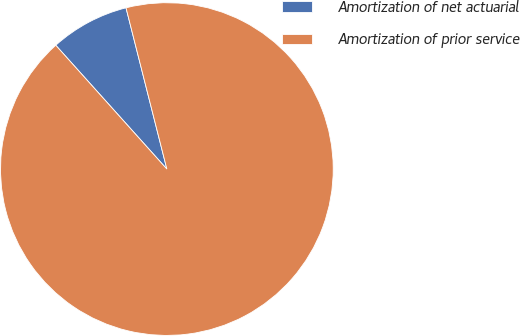<chart> <loc_0><loc_0><loc_500><loc_500><pie_chart><fcel>Amortization of net actuarial<fcel>Amortization of prior service<nl><fcel>7.69%<fcel>92.31%<nl></chart> 